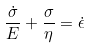<formula> <loc_0><loc_0><loc_500><loc_500>\frac { \dot { \sigma } } { E } + \frac { \sigma } { \eta } = \dot { \epsilon }</formula> 